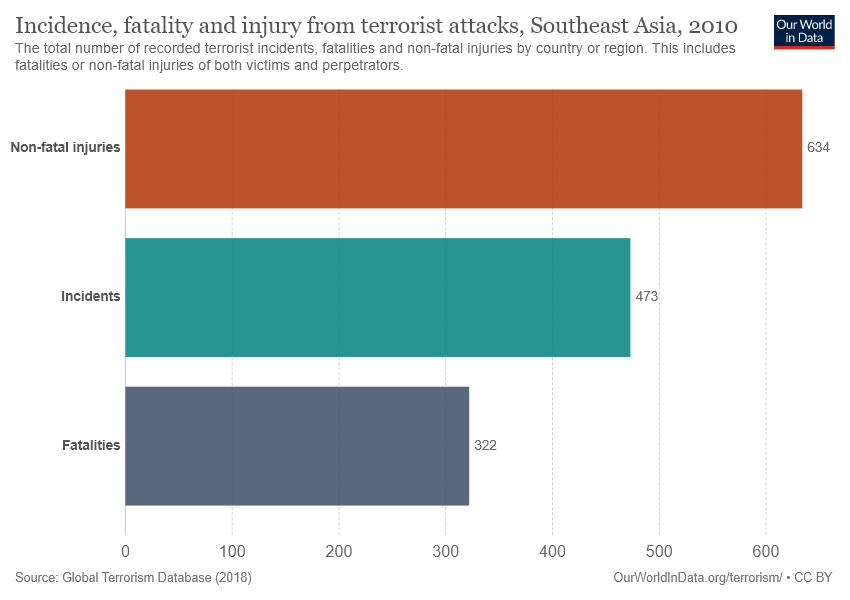Give some essential details in this illustration. The value of the largest bar is 634. The difference in value between the largest and smallest bar in the given range is 312. 